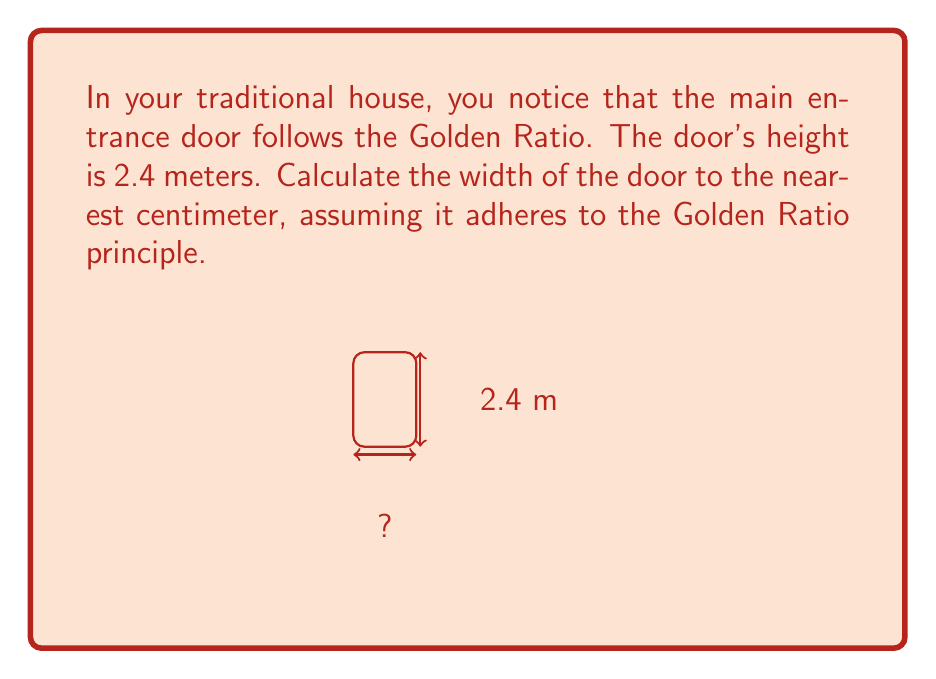Could you help me with this problem? Let's approach this step-by-step:

1) The Golden Ratio, often denoted by φ (phi), is approximately equal to 1.618033988749895.

2) In a Golden Rectangle, the ratio of the longer side to the shorter side is equal to φ.

3) We are given that the height of the door is 2.4 meters. Let's call the width x meters.

4) According to the Golden Ratio principle:

   $$\frac{\text{height}}{\text{width}} = φ$$

5) Substituting our known values:

   $$\frac{2.4}{x} = 1.618033988749895$$

6) To solve for x, multiply both sides by x:

   $$2.4 = 1.618033988749895x$$

7) Now divide both sides by 1.618033988749895:

   $$x = \frac{2.4}{1.618033988749895} ≈ 1.4832 \text{ meters}$$

8) Converting to centimeters and rounding to the nearest centimeter:

   $$1.4832 \text{ m} * 100 \text{ cm/m} ≈ 148.32 \text{ cm} ≈ 148 \text{ cm}$$
Answer: 148 cm 